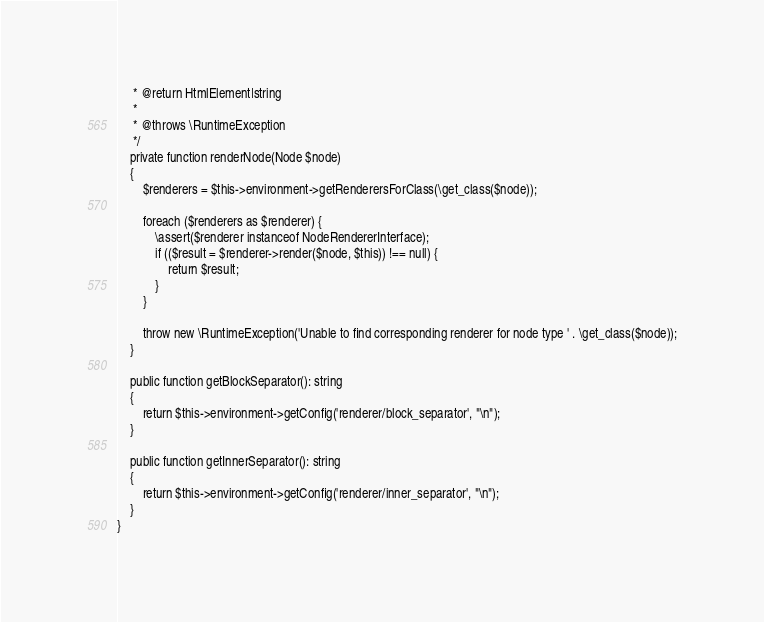<code> <loc_0><loc_0><loc_500><loc_500><_PHP_>     * @return HtmlElement|string
     *
     * @throws \RuntimeException
     */
    private function renderNode(Node $node)
    {
        $renderers = $this->environment->getRenderersForClass(\get_class($node));

        foreach ($renderers as $renderer) {
            \assert($renderer instanceof NodeRendererInterface);
            if (($result = $renderer->render($node, $this)) !== null) {
                return $result;
            }
        }

        throw new \RuntimeException('Unable to find corresponding renderer for node type ' . \get_class($node));
    }

    public function getBlockSeparator(): string
    {
        return $this->environment->getConfig('renderer/block_separator', "\n");
    }

    public function getInnerSeparator(): string
    {
        return $this->environment->getConfig('renderer/inner_separator', "\n");
    }
}
</code> 